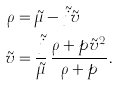Convert formula to latex. <formula><loc_0><loc_0><loc_500><loc_500>\rho & = \tilde { \mu } - \tilde { j } \tilde { v } \\ \tilde { v } & = \frac { \tilde { j } } { \tilde { \mu } } \, \frac { \rho + p \tilde { v } ^ { 2 } } { \rho + p } .</formula> 